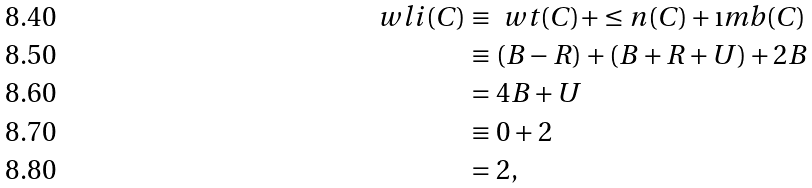Convert formula to latex. <formula><loc_0><loc_0><loc_500><loc_500>\ w l i ( C ) & \equiv \ w t ( C ) + \leq n ( C ) + \i m b ( C ) \\ & \equiv ( B - R ) + ( B + R + U ) + 2 B \\ & = 4 B + U \\ & \equiv 0 + 2 \\ & = 2 ,</formula> 